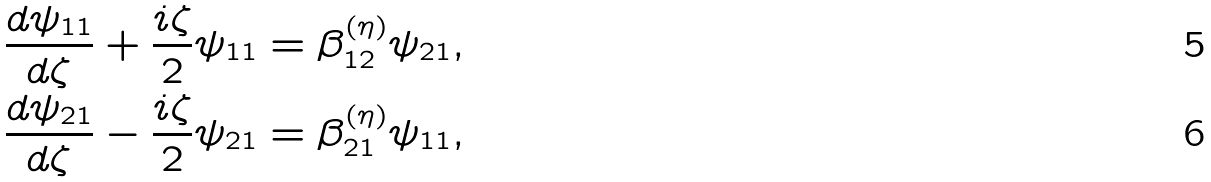<formula> <loc_0><loc_0><loc_500><loc_500>\frac { d \psi _ { 1 1 } } { d \zeta } + \frac { i \zeta } { 2 } \psi _ { 1 1 } = \beta ^ { ( \eta ) } _ { 1 2 } \psi _ { 2 1 } , \\ \frac { d \psi _ { 2 1 } } { d \zeta } - \frac { i \zeta } { 2 } \psi _ { 2 1 } = \beta ^ { ( \eta ) } _ { 2 1 } \psi _ { 1 1 } ,</formula> 